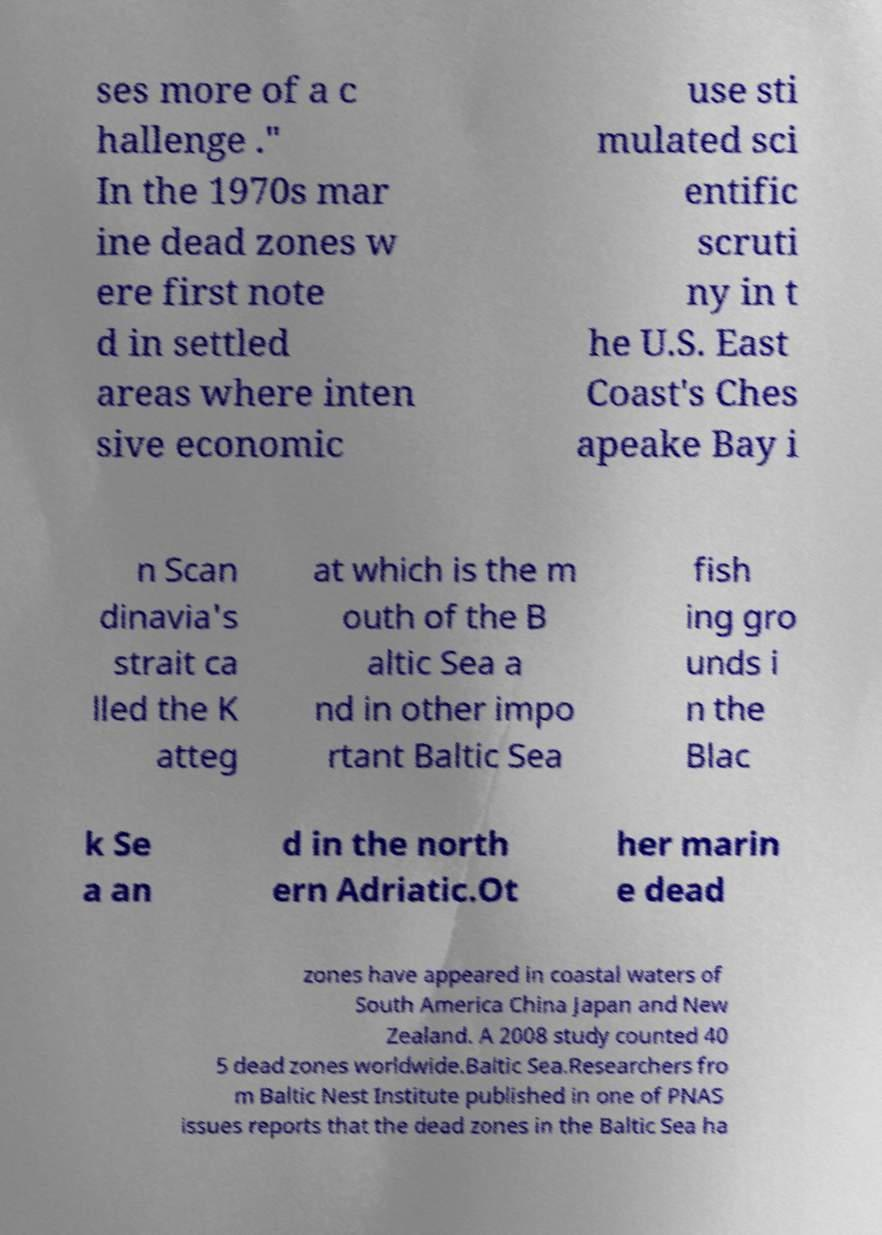Can you accurately transcribe the text from the provided image for me? ses more of a c hallenge ." In the 1970s mar ine dead zones w ere first note d in settled areas where inten sive economic use sti mulated sci entific scruti ny in t he U.S. East Coast's Ches apeake Bay i n Scan dinavia's strait ca lled the K atteg at which is the m outh of the B altic Sea a nd in other impo rtant Baltic Sea fish ing gro unds i n the Blac k Se a an d in the north ern Adriatic.Ot her marin e dead zones have appeared in coastal waters of South America China Japan and New Zealand. A 2008 study counted 40 5 dead zones worldwide.Baltic Sea.Researchers fro m Baltic Nest Institute published in one of PNAS issues reports that the dead zones in the Baltic Sea ha 